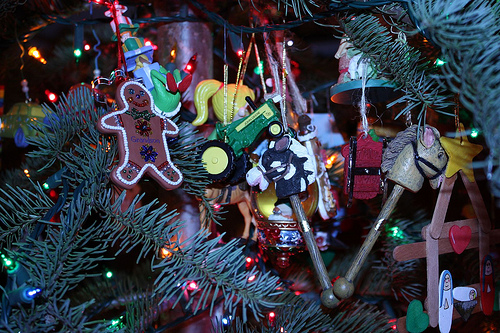<image>
Is there a girl on the horse? No. The girl is not positioned on the horse. They may be near each other, but the girl is not supported by or resting on top of the horse. 